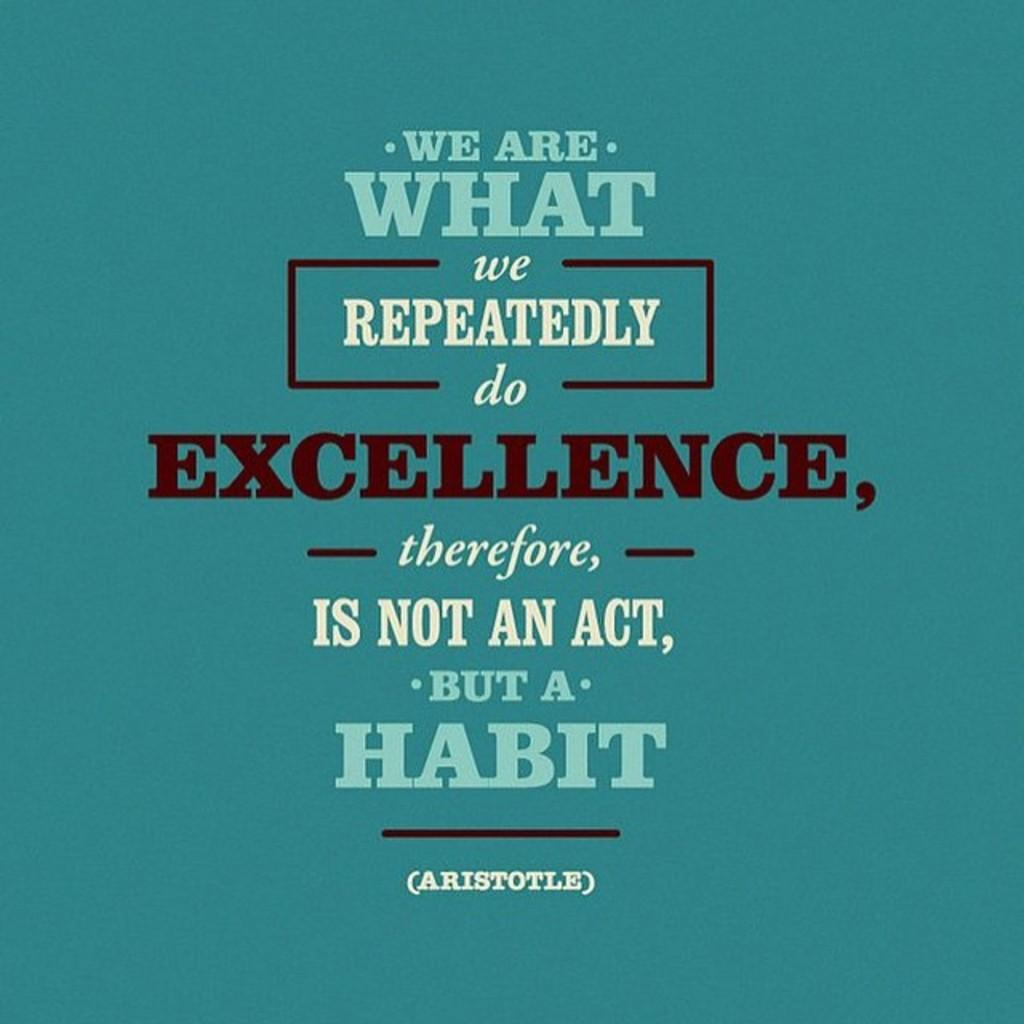<image>
Describe the image concisely. a blue poster with a quote from Aristotle with words We Are What on it 